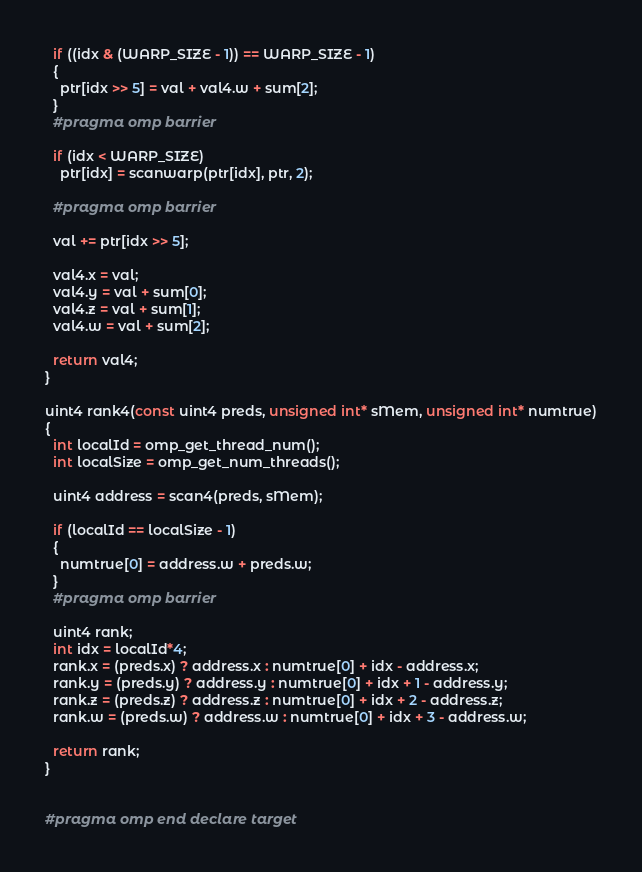<code> <loc_0><loc_0><loc_500><loc_500><_C++_>
  if ((idx & (WARP_SIZE - 1)) == WARP_SIZE - 1)
  {
    ptr[idx >> 5] = val + val4.w + sum[2];
  }
  #pragma omp barrier

  if (idx < WARP_SIZE)
    ptr[idx] = scanwarp(ptr[idx], ptr, 2);

  #pragma omp barrier

  val += ptr[idx >> 5];

  val4.x = val;
  val4.y = val + sum[0];
  val4.z = val + sum[1];
  val4.w = val + sum[2];

  return val4;
}

uint4 rank4(const uint4 preds, unsigned int* sMem, unsigned int* numtrue)
{
  int localId = omp_get_thread_num();
  int localSize = omp_get_num_threads();

  uint4 address = scan4(preds, sMem);

  if (localId == localSize - 1) 
  {
    numtrue[0] = address.w + preds.w;
  }
  #pragma omp barrier

  uint4 rank;
  int idx = localId*4;
  rank.x = (preds.x) ? address.x : numtrue[0] + idx - address.x;
  rank.y = (preds.y) ? address.y : numtrue[0] + idx + 1 - address.y;
  rank.z = (preds.z) ? address.z : numtrue[0] + idx + 2 - address.z;
  rank.w = (preds.w) ? address.w : numtrue[0] + idx + 3 - address.w;

  return rank;
}


#pragma omp end declare target 
</code> 